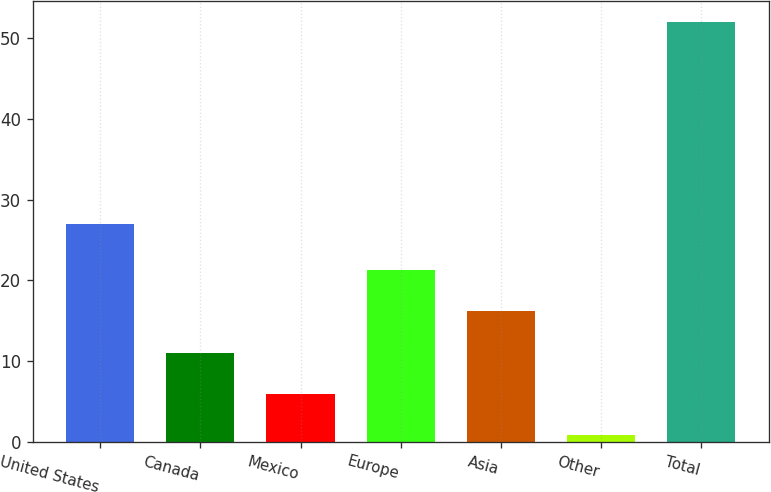Convert chart. <chart><loc_0><loc_0><loc_500><loc_500><bar_chart><fcel>United States<fcel>Canada<fcel>Mexico<fcel>Europe<fcel>Asia<fcel>Other<fcel>Total<nl><fcel>27<fcel>11.09<fcel>5.98<fcel>21.31<fcel>16.2<fcel>0.87<fcel>52<nl></chart> 